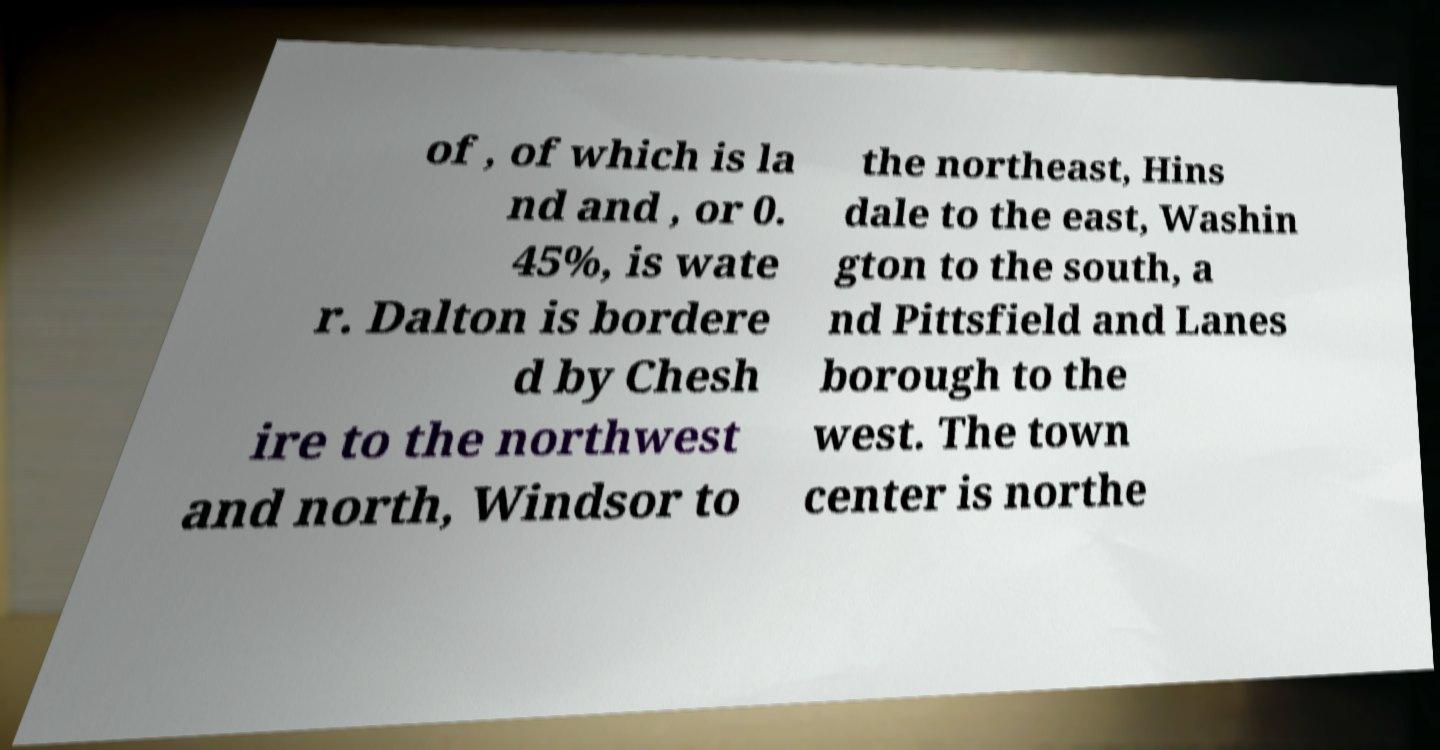Please identify and transcribe the text found in this image. of , of which is la nd and , or 0. 45%, is wate r. Dalton is bordere d by Chesh ire to the northwest and north, Windsor to the northeast, Hins dale to the east, Washin gton to the south, a nd Pittsfield and Lanes borough to the west. The town center is northe 